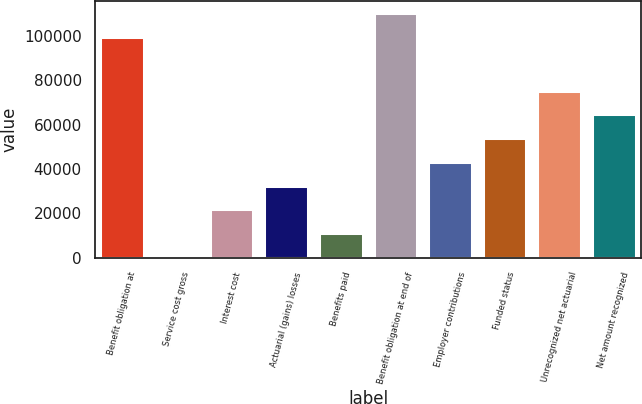<chart> <loc_0><loc_0><loc_500><loc_500><bar_chart><fcel>Benefit obligation at<fcel>Service cost gross<fcel>Interest cost<fcel>Actuarial (gains) losses<fcel>Benefits paid<fcel>Benefit obligation at end of<fcel>Employer contributions<fcel>Funded status<fcel>Unrecognized net actuarial<fcel>Net amount recognized<nl><fcel>99795<fcel>506<fcel>21893.8<fcel>32587.7<fcel>11199.9<fcel>110489<fcel>43281.6<fcel>53975.5<fcel>75363.3<fcel>64669.4<nl></chart> 